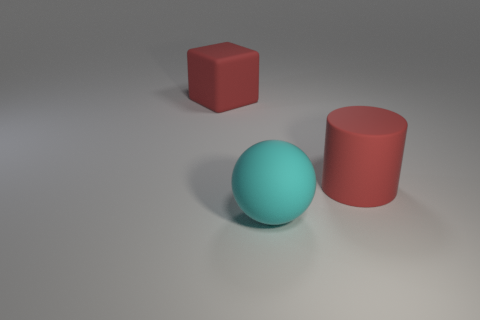How many other objects are the same material as the ball?
Offer a very short reply. 2. There is a big thing that is behind the red thing to the right of the cyan object; what is its shape?
Your response must be concise. Cube. How many objects are red rubber cylinders or cyan matte spheres right of the large matte block?
Your answer should be compact. 2. How many other objects are there of the same color as the rubber block?
Make the answer very short. 1. What number of red things are either big matte things or large balls?
Provide a short and direct response. 2. Are there any big matte cylinders that are on the right side of the big red matte object that is to the left of the red rubber thing that is on the right side of the cyan rubber thing?
Offer a terse response. Yes. Does the big cylinder have the same color as the cube?
Offer a very short reply. Yes. There is a rubber object that is in front of the large red matte thing that is right of the big red cube; what is its color?
Keep it short and to the point. Cyan. What number of small objects are either cyan rubber balls or purple metallic balls?
Provide a succinct answer. 0. There is a thing that is both right of the block and behind the cyan thing; what color is it?
Your answer should be very brief. Red. 